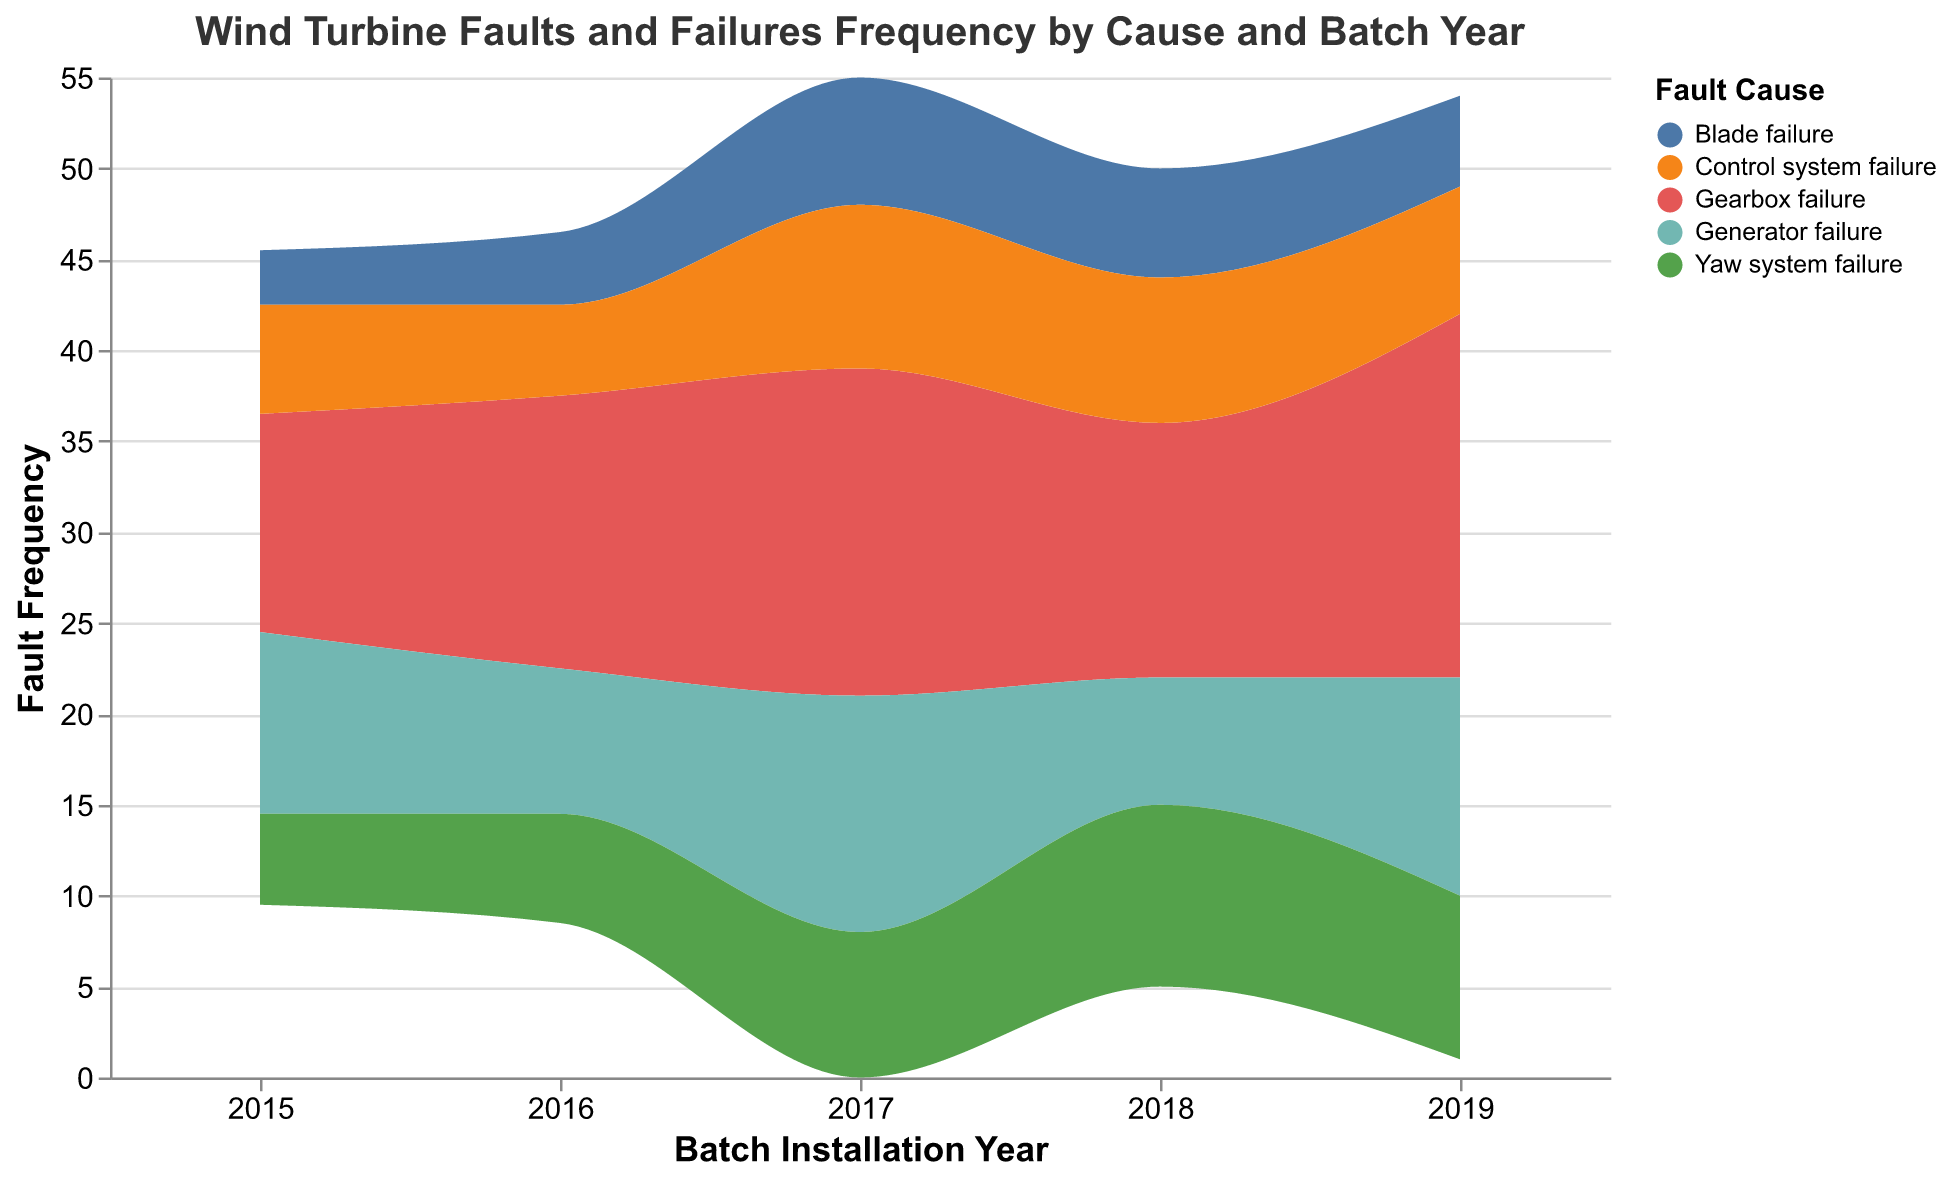What is the overall trend in gearbox failures from 2015 to 2019? From 2015 to 2017, gearbox failures increase from 12 to 18. Then, there is a slight decrease to 14 in 2018, followed by an increase to 20 in 2019. Thus, the general trend is an overall increase.
Answer: Increasing Which fault cause had the highest frequency in 2019? To answer, observe the color bands for 2019. The gray color band, representing gearbox failure, is the highest at 20.
Answer: Gearbox failure How does the frequency of generator failures in 2018 compare to 2019? Refer to the color associated with generator failures and compare the heights of the respective color segments for 2018 and 2019. The frequency in 2018 is 7, and in 2019 it is 12.
Answer: 2019 is higher By approximately how much did the frequency of yaw system failures change between 2018 and 2019? Look at the heights of the segments for yaw system failures (green) in 2018 (10) and 2019 (9). The difference is 1.
Answer: Decreased by 1 Which year had the lowest total fault frequency across all fault causes? Sum the heights of all segments for each year. 2015 has (12+10+5+3+6)=36; 2016 has (15+8+6+4+5)=38; 2017 has (18+13+8+7+9)=55; 2018 has (14+7+10+6+8)=45; 2019 has (20+12+9+5+7)=53.
Answer: 2015 What is the total fault frequency for blade failures from 2015 to 2019? Sum the frequencies for blade failures for each year: 3 (2015) + 4 (2016) + 7 (2017) + 6 (2018) + 5 (2019). The total is 25.
Answer: 25 How does the trend of control system failures compare to gearbox failures over the years? Gearbox failures show an increasing trend with slight fluctuations, while control system failures peak in 2017 (9) and then decrease gradually back to the 2015 level (6).
Answer: Different trends Which two years show the largest increase in gearbox failure frequency? The frequencies are: 2015 (12), 2016 (15), 2017 (18), 2018 (14), 2019 (20). The largest increases are between 2017-2018 and 2018-2019.
Answer: 2018-2019 Compare the fault frequency trends for generator and yaw system failures. Generator failures decrease over time with fluctuations: 10 (2015), 8 (2016), 13 (2017), 7 (2018), 12 (2019). Yaw system failures increase steadily until 2018 and then slightly decrease in 2019: 5 (2015), 6 (2016), 8 (2017), 10 (2018), 9 (2019).
Answer: Divergent trends 